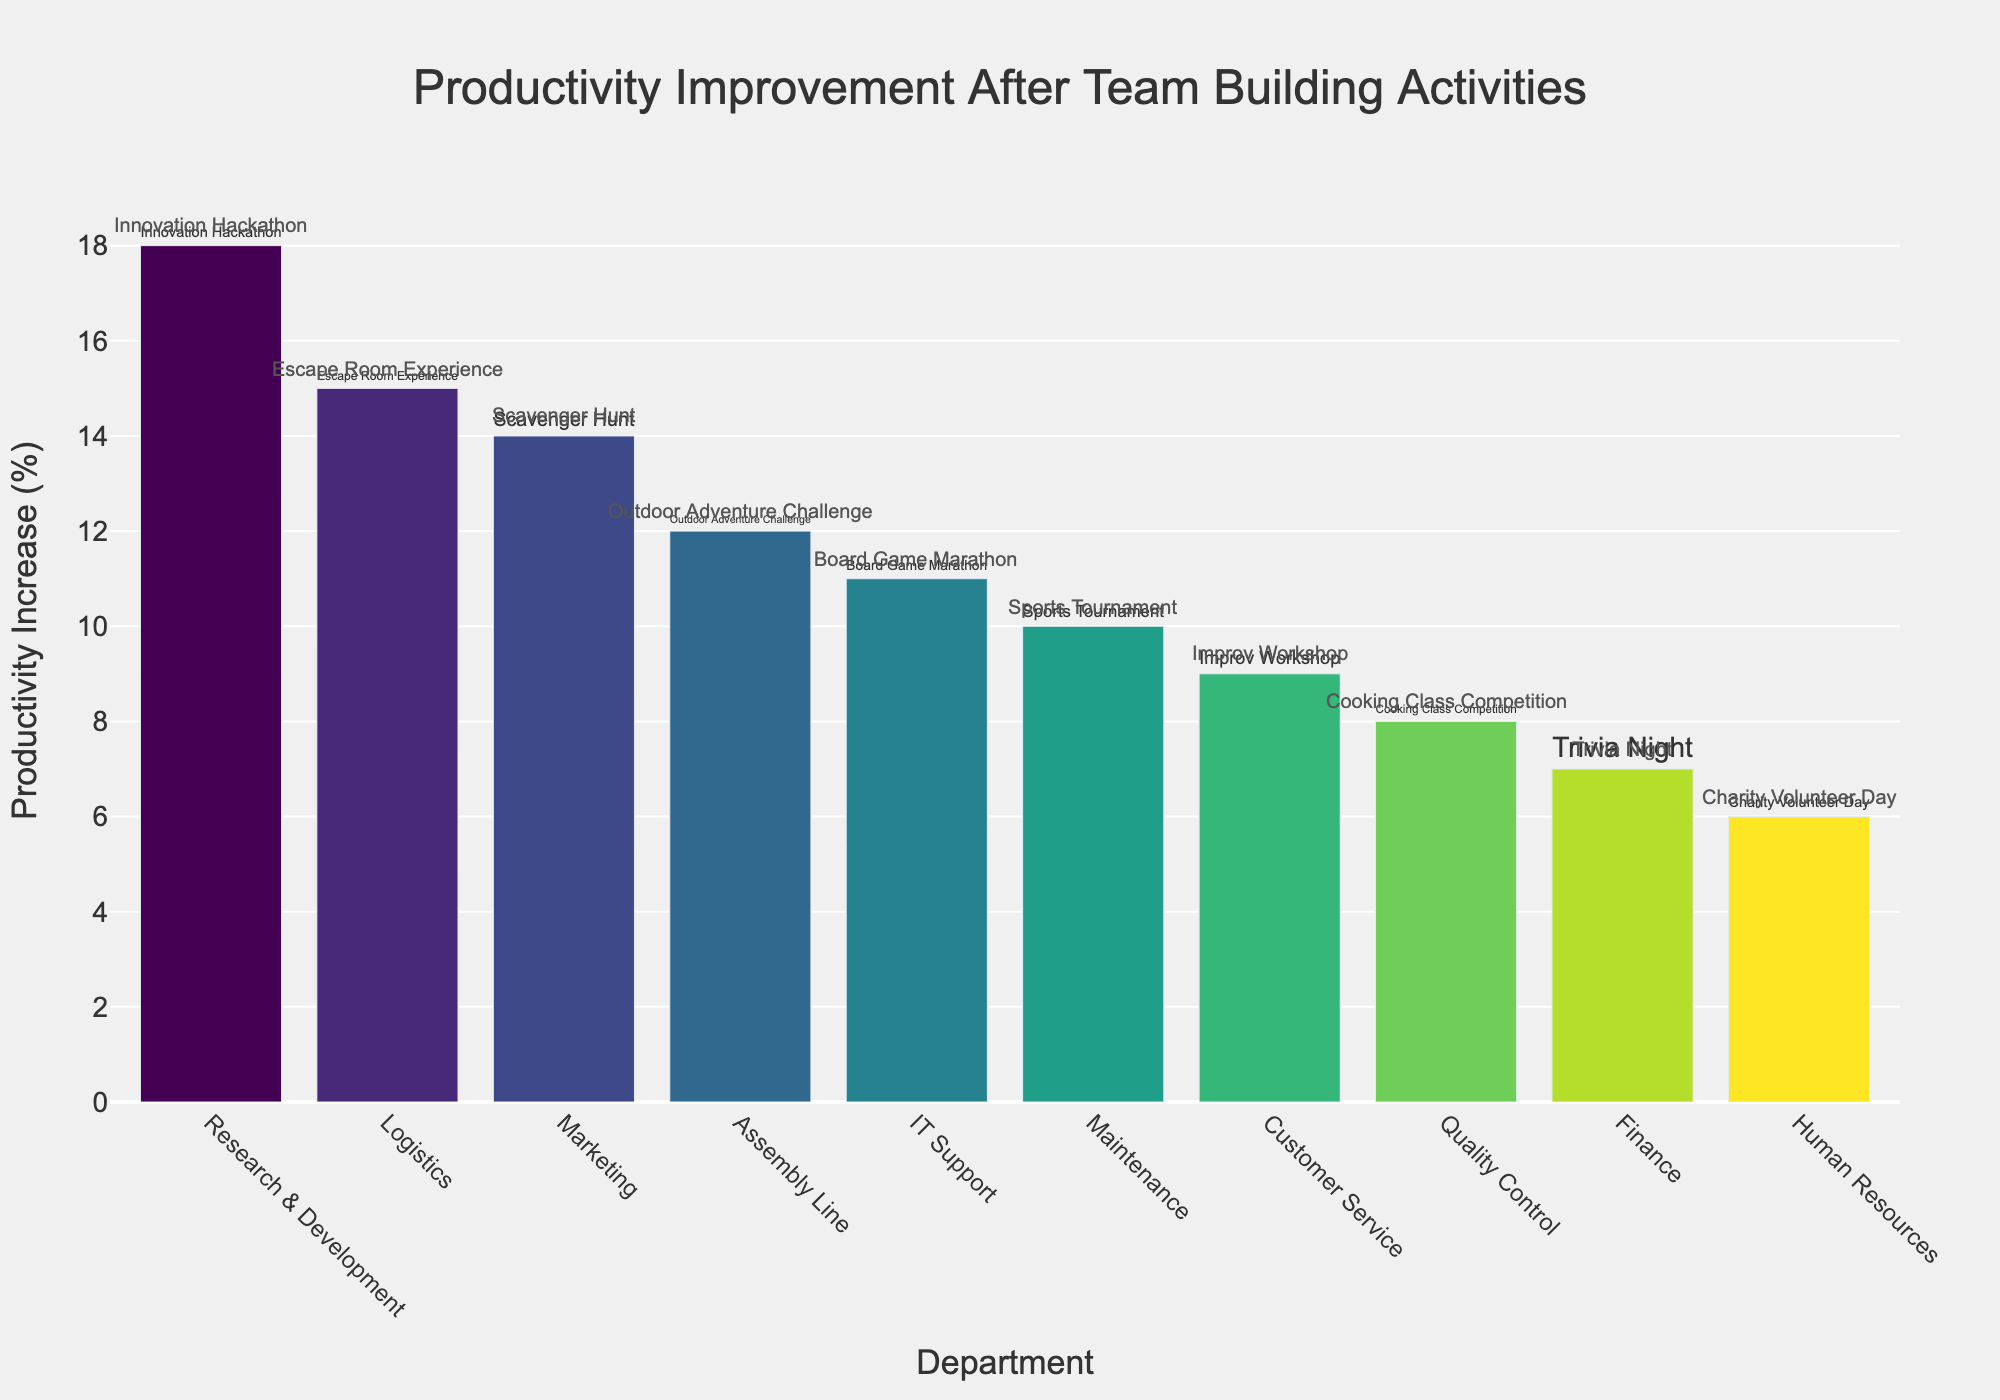Which department saw the highest productivity increase after their team-building activity? The tallest bar in the chart represents the department with the highest productivity increase. By observing the chart, it is evident that the Research & Development department has the tallest bar.
Answer: Research & Development What is the productivity increase difference between the Marketing and the Finance departments? By looking at the heights of the bars for Marketing and Finance, Marketing has a productivity increase of 14%, while Finance has 7%. The difference is 14% - 7%.
Answer: 7% Which team-building activity resulted in a 15% productivity increase? The bar corresponding to the Logistics department shows a 15% productivity increase, and the attached activity text identifies it as the Escape Room Experience.
Answer: Escape Room Experience Which departments have a productivity increase of more than 10%? After observing the heights of the bars, the departments with over 10% productivity increase are Assembly Line, Logistics, Maintenance, Research & Development, Marketing, and IT Support.
Answer: Assembly Line, Logistics, Maintenance, Research & Development, Marketing, IT Support What is the average productivity increase of all departments? Sum the productivity increases for all ten departments (12% + 8% + 15% + 6% + 10% + 18% + 9% + 14% + 7% + 11%) which equals 110%. Dividing by the number of departments (10) gives an average increase of 110%/10.
Answer: 11% Which department has the least productivity improvement and what activity was it attributed to? The shortest bar corresponds to the department with the lowest productivity increase. The Human Resources department has the shortest bar with a 6% increase, attributed to the Charity Volunteer Day activity.
Answer: Human Resources, Charity Volunteer Day How many departments have a productivity increase precisely between 8% and 14% inclusive? By checking each bar within the given range, the departments are Quality Control (8%), Customer Service (9%), IT Support (11%), and Marketing (14%). Four departments fall into this range.
Answer: 4 What is the total productivity increase for the Assembly Line, Maintenance, and IT Support departments combined? Sum their individual increases: Assembly Line (12%) + Maintenance (10%) + IT Support (11%) = 12% + 10% + 11%.
Answer: 33% Which team-building activity was associated with a 12% productivity increase? By looking at the bars and their associated texts, the Assembly Line department's 12% productivity increase is linked to the Outdoor Adventure Challenge activity.
Answer: Outdoor Adventure Challenge 